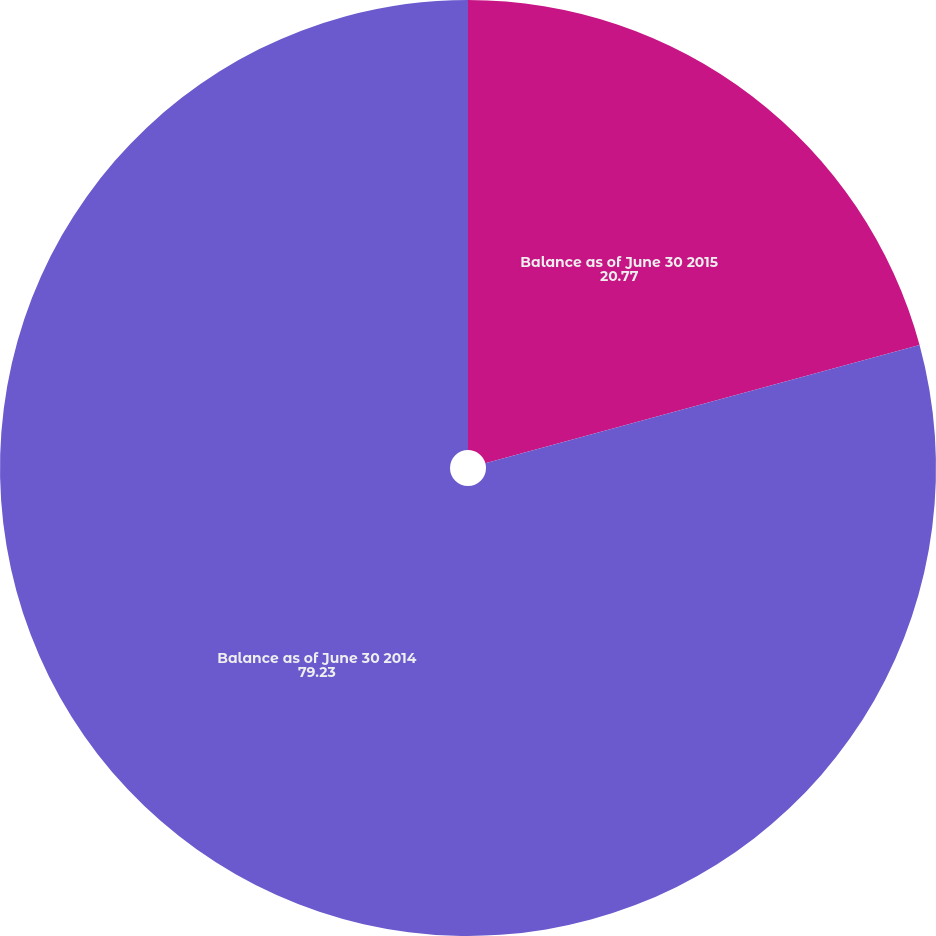Convert chart. <chart><loc_0><loc_0><loc_500><loc_500><pie_chart><fcel>Balance as of June 30 2015<fcel>Balance as of June 30 2014<nl><fcel>20.77%<fcel>79.23%<nl></chart> 